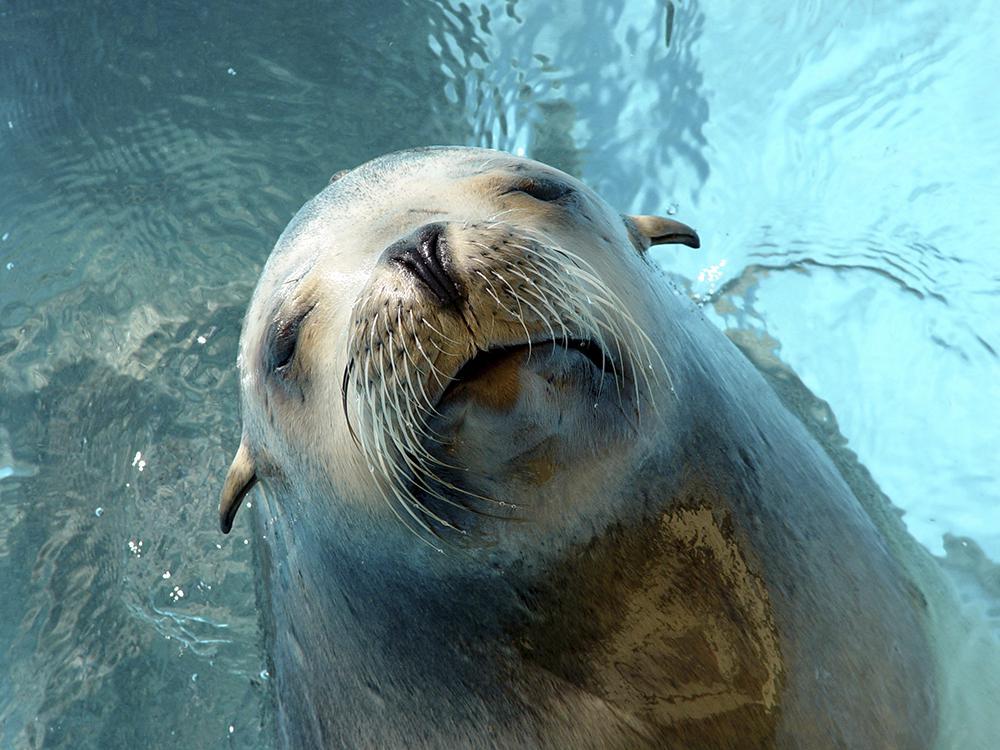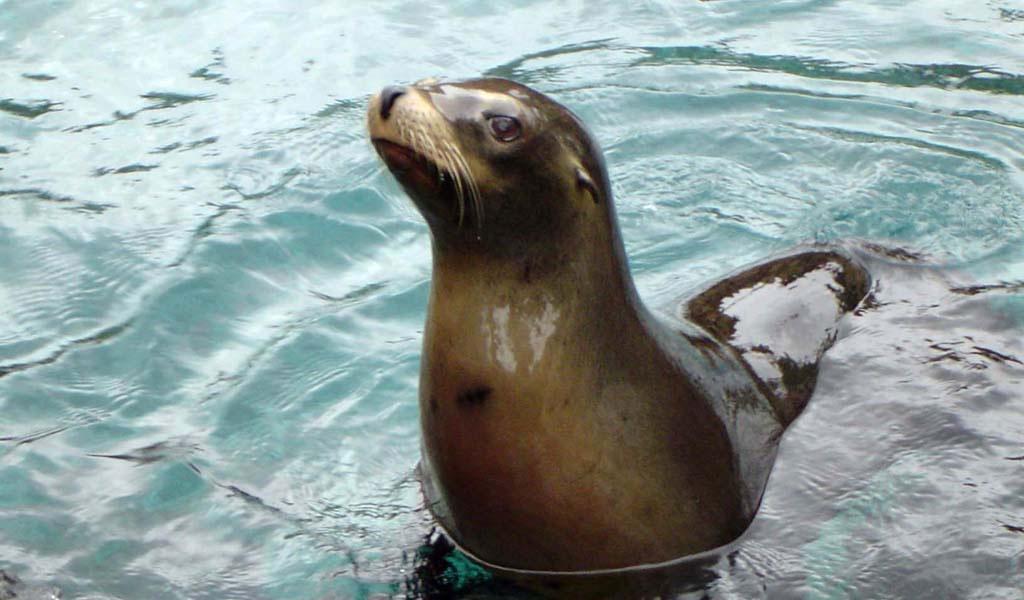The first image is the image on the left, the second image is the image on the right. For the images displayed, is the sentence "The mouth of the seal in one of the images is open." factually correct? Answer yes or no. No. The first image is the image on the left, the second image is the image on the right. For the images displayed, is the sentence "A seal's body is submerged in water up to its neck in one of the images." factually correct? Answer yes or no. Yes. 